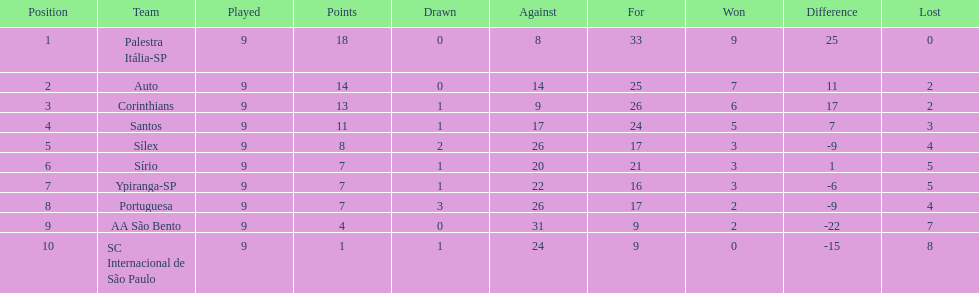In 1926 brazilian football,aside from the first place team, what other teams had winning records? Auto, Corinthians, Santos. 